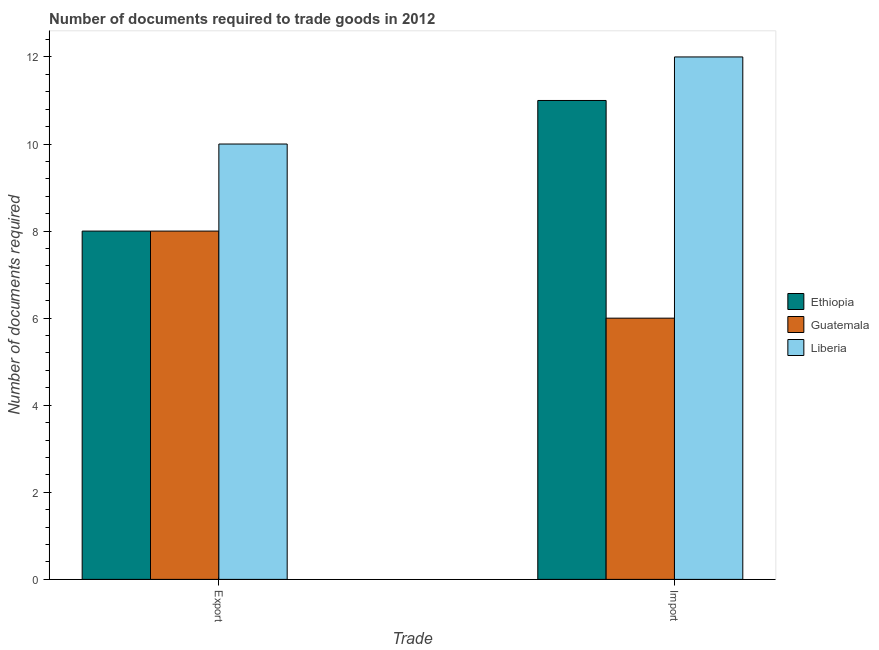How many different coloured bars are there?
Your answer should be compact. 3. How many groups of bars are there?
Make the answer very short. 2. Are the number of bars per tick equal to the number of legend labels?
Your answer should be very brief. Yes. Are the number of bars on each tick of the X-axis equal?
Make the answer very short. Yes. What is the label of the 1st group of bars from the left?
Give a very brief answer. Export. What is the number of documents required to export goods in Guatemala?
Ensure brevity in your answer.  8. Across all countries, what is the maximum number of documents required to export goods?
Make the answer very short. 10. Across all countries, what is the minimum number of documents required to export goods?
Give a very brief answer. 8. In which country was the number of documents required to export goods maximum?
Your answer should be very brief. Liberia. In which country was the number of documents required to import goods minimum?
Provide a short and direct response. Guatemala. What is the total number of documents required to import goods in the graph?
Your response must be concise. 29. What is the difference between the number of documents required to import goods in Liberia and the number of documents required to export goods in Ethiopia?
Your answer should be very brief. 4. What is the average number of documents required to export goods per country?
Provide a short and direct response. 8.67. What is the difference between the number of documents required to export goods and number of documents required to import goods in Liberia?
Offer a terse response. -2. In how many countries, is the number of documents required to export goods greater than 4.8 ?
Give a very brief answer. 3. What is the ratio of the number of documents required to import goods in Ethiopia to that in Guatemala?
Provide a succinct answer. 1.83. In how many countries, is the number of documents required to export goods greater than the average number of documents required to export goods taken over all countries?
Offer a very short reply. 1. What does the 1st bar from the left in Export represents?
Your response must be concise. Ethiopia. What does the 2nd bar from the right in Export represents?
Ensure brevity in your answer.  Guatemala. Are all the bars in the graph horizontal?
Ensure brevity in your answer.  No. How many countries are there in the graph?
Keep it short and to the point. 3. Are the values on the major ticks of Y-axis written in scientific E-notation?
Provide a short and direct response. No. Does the graph contain any zero values?
Provide a short and direct response. No. Does the graph contain grids?
Make the answer very short. No. How many legend labels are there?
Your response must be concise. 3. What is the title of the graph?
Provide a succinct answer. Number of documents required to trade goods in 2012. Does "Jordan" appear as one of the legend labels in the graph?
Ensure brevity in your answer.  No. What is the label or title of the X-axis?
Keep it short and to the point. Trade. What is the label or title of the Y-axis?
Provide a short and direct response. Number of documents required. What is the Number of documents required of Guatemala in Export?
Offer a terse response. 8. What is the Number of documents required in Guatemala in Import?
Offer a terse response. 6. What is the Number of documents required of Liberia in Import?
Give a very brief answer. 12. Across all Trade, what is the maximum Number of documents required of Liberia?
Your answer should be compact. 12. What is the total Number of documents required of Guatemala in the graph?
Provide a succinct answer. 14. What is the difference between the Number of documents required in Liberia in Export and that in Import?
Keep it short and to the point. -2. What is the difference between the Number of documents required of Guatemala in Export and the Number of documents required of Liberia in Import?
Your response must be concise. -4. What is the average Number of documents required of Ethiopia per Trade?
Keep it short and to the point. 9.5. What is the average Number of documents required of Liberia per Trade?
Offer a terse response. 11. What is the difference between the Number of documents required in Ethiopia and Number of documents required in Guatemala in Export?
Give a very brief answer. 0. What is the difference between the Number of documents required in Guatemala and Number of documents required in Liberia in Export?
Your response must be concise. -2. What is the difference between the Number of documents required of Ethiopia and Number of documents required of Guatemala in Import?
Your response must be concise. 5. What is the difference between the Number of documents required of Guatemala and Number of documents required of Liberia in Import?
Ensure brevity in your answer.  -6. What is the ratio of the Number of documents required in Ethiopia in Export to that in Import?
Offer a very short reply. 0.73. What is the ratio of the Number of documents required of Guatemala in Export to that in Import?
Provide a succinct answer. 1.33. What is the difference between the highest and the second highest Number of documents required in Liberia?
Offer a very short reply. 2. 